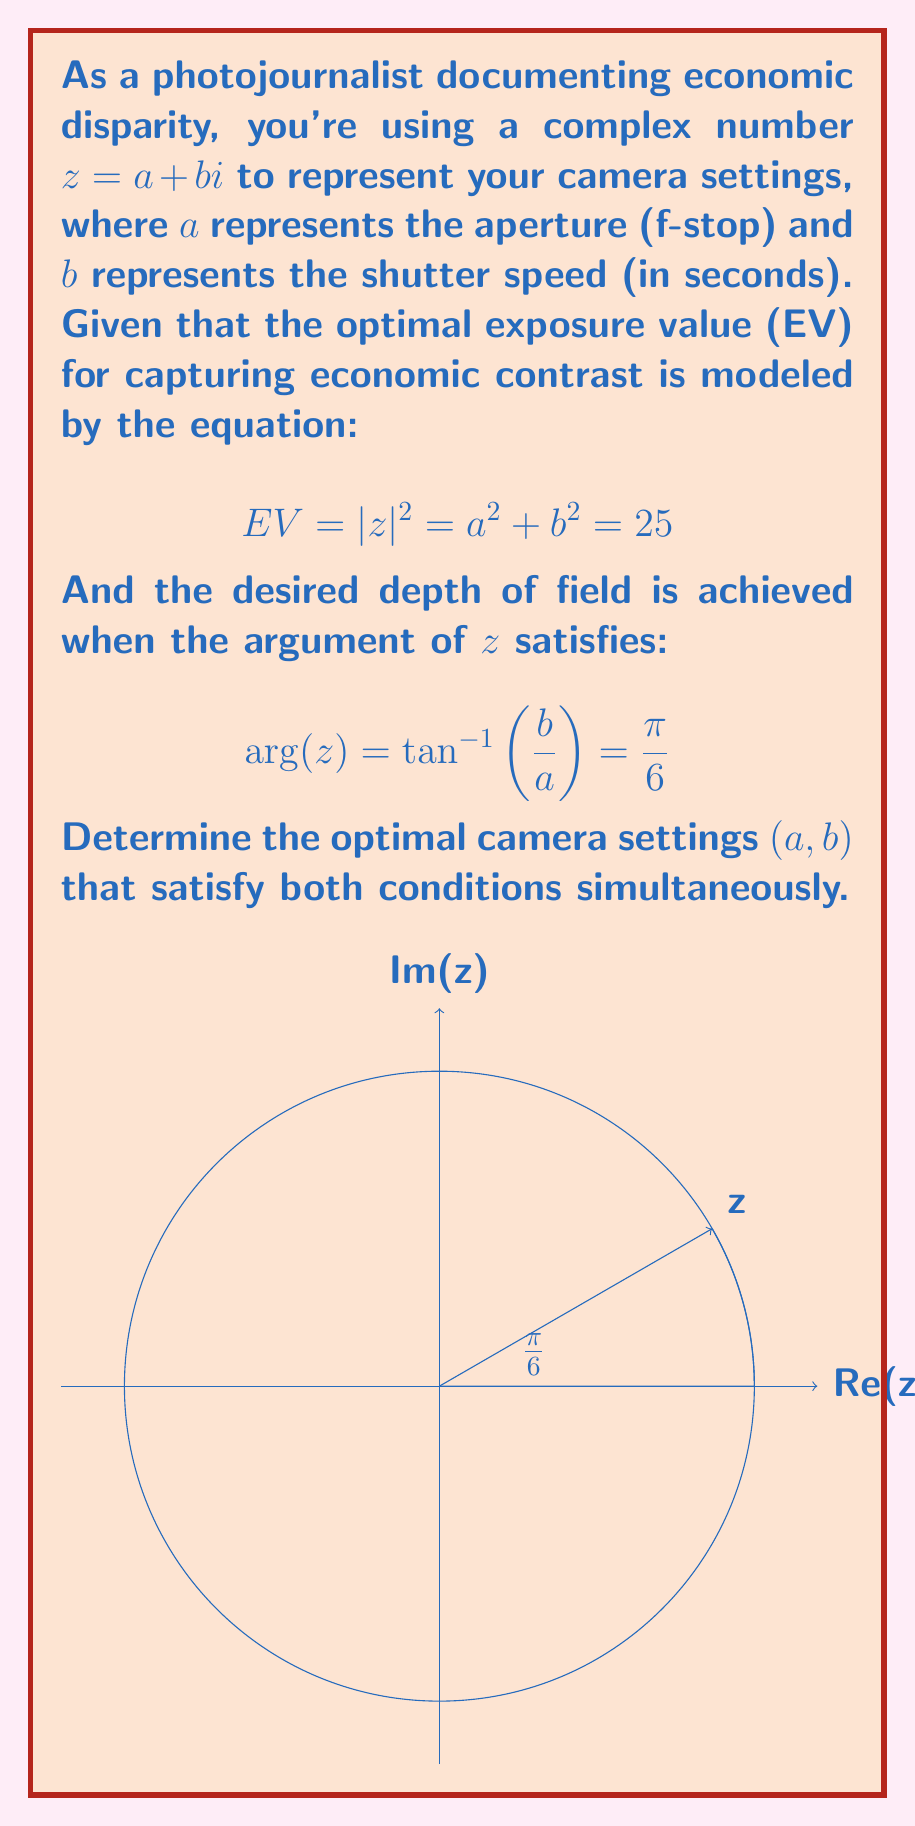Show me your answer to this math problem. Let's approach this step-by-step:

1) We have two conditions to satisfy:
   a) $|z|^2 = a^2 + b^2 = 25$
   b) $\arg(z) = \tan^{-1}(\frac{b}{a}) = \frac{\pi}{6}$

2) From the argument condition, we can deduce:
   $\tan(\frac{\pi}{6}) = \frac{b}{a}$
   
3) We know that $\tan(\frac{\pi}{6}) = \frac{1}{\sqrt{3}}$, so:
   $\frac{b}{a} = \frac{1}{\sqrt{3}}$

4) This means $b = \frac{a}{\sqrt{3}}$

5) Substituting this into the magnitude condition:
   $a^2 + (\frac{a}{\sqrt{3}})^2 = 25$

6) Simplifying:
   $a^2 + \frac{a^2}{3} = 25$
   $\frac{4a^2}{3} = 25$
   $a^2 = \frac{75}{4}$

7) Solving for $a$:
   $a = \frac{\sqrt{75}}{2} = \frac{5\sqrt{3}}{2}$

8) Now we can find $b$:
   $b = \frac{a}{\sqrt{3}} = \frac{5\sqrt{3}}{2\sqrt{3}} = \frac{5}{2}$

9) Therefore, the optimal camera settings are:
   $a = \frac{5\sqrt{3}}{2}$ (aperture)
   $b = \frac{5}{2}$ (shutter speed)

10) We can verify:
    $|z|^2 = (\frac{5\sqrt{3}}{2})^2 + (\frac{5}{2})^2 = \frac{75}{4} + \frac{25}{4} = 25$
    $\arg(z) = \tan^{-1}(\frac{5/2}{5\sqrt{3}/2}) = \tan^{-1}(\frac{1}{\sqrt{3}}) = \frac{\pi}{6}$
Answer: $a = \frac{5\sqrt{3}}{2}, b = \frac{5}{2}$ 